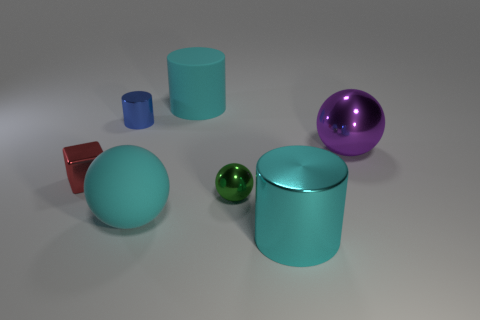What is the size of the sphere that is on the right side of the large cyan cylinder that is in front of the small green metal ball?
Provide a succinct answer. Large. The thing that is right of the blue cylinder and left of the rubber cylinder is what color?
Provide a short and direct response. Cyan. What number of other objects are the same size as the green metallic ball?
Offer a very short reply. 2. Does the cyan metal thing have the same size as the cyan rubber object that is behind the small blue object?
Make the answer very short. Yes. There is a block that is the same size as the blue shiny cylinder; what color is it?
Provide a short and direct response. Red. How big is the green sphere?
Provide a short and direct response. Small. Do the large cylinder that is in front of the tiny cube and the purple sphere have the same material?
Provide a succinct answer. Yes. Does the tiny red shiny thing have the same shape as the large purple object?
Offer a terse response. No. The large thing to the right of the large cyan cylinder to the right of the large cyan cylinder behind the tiny block is what shape?
Make the answer very short. Sphere. There is a matte thing on the right side of the large cyan sphere; does it have the same shape as the small object behind the block?
Keep it short and to the point. Yes. 